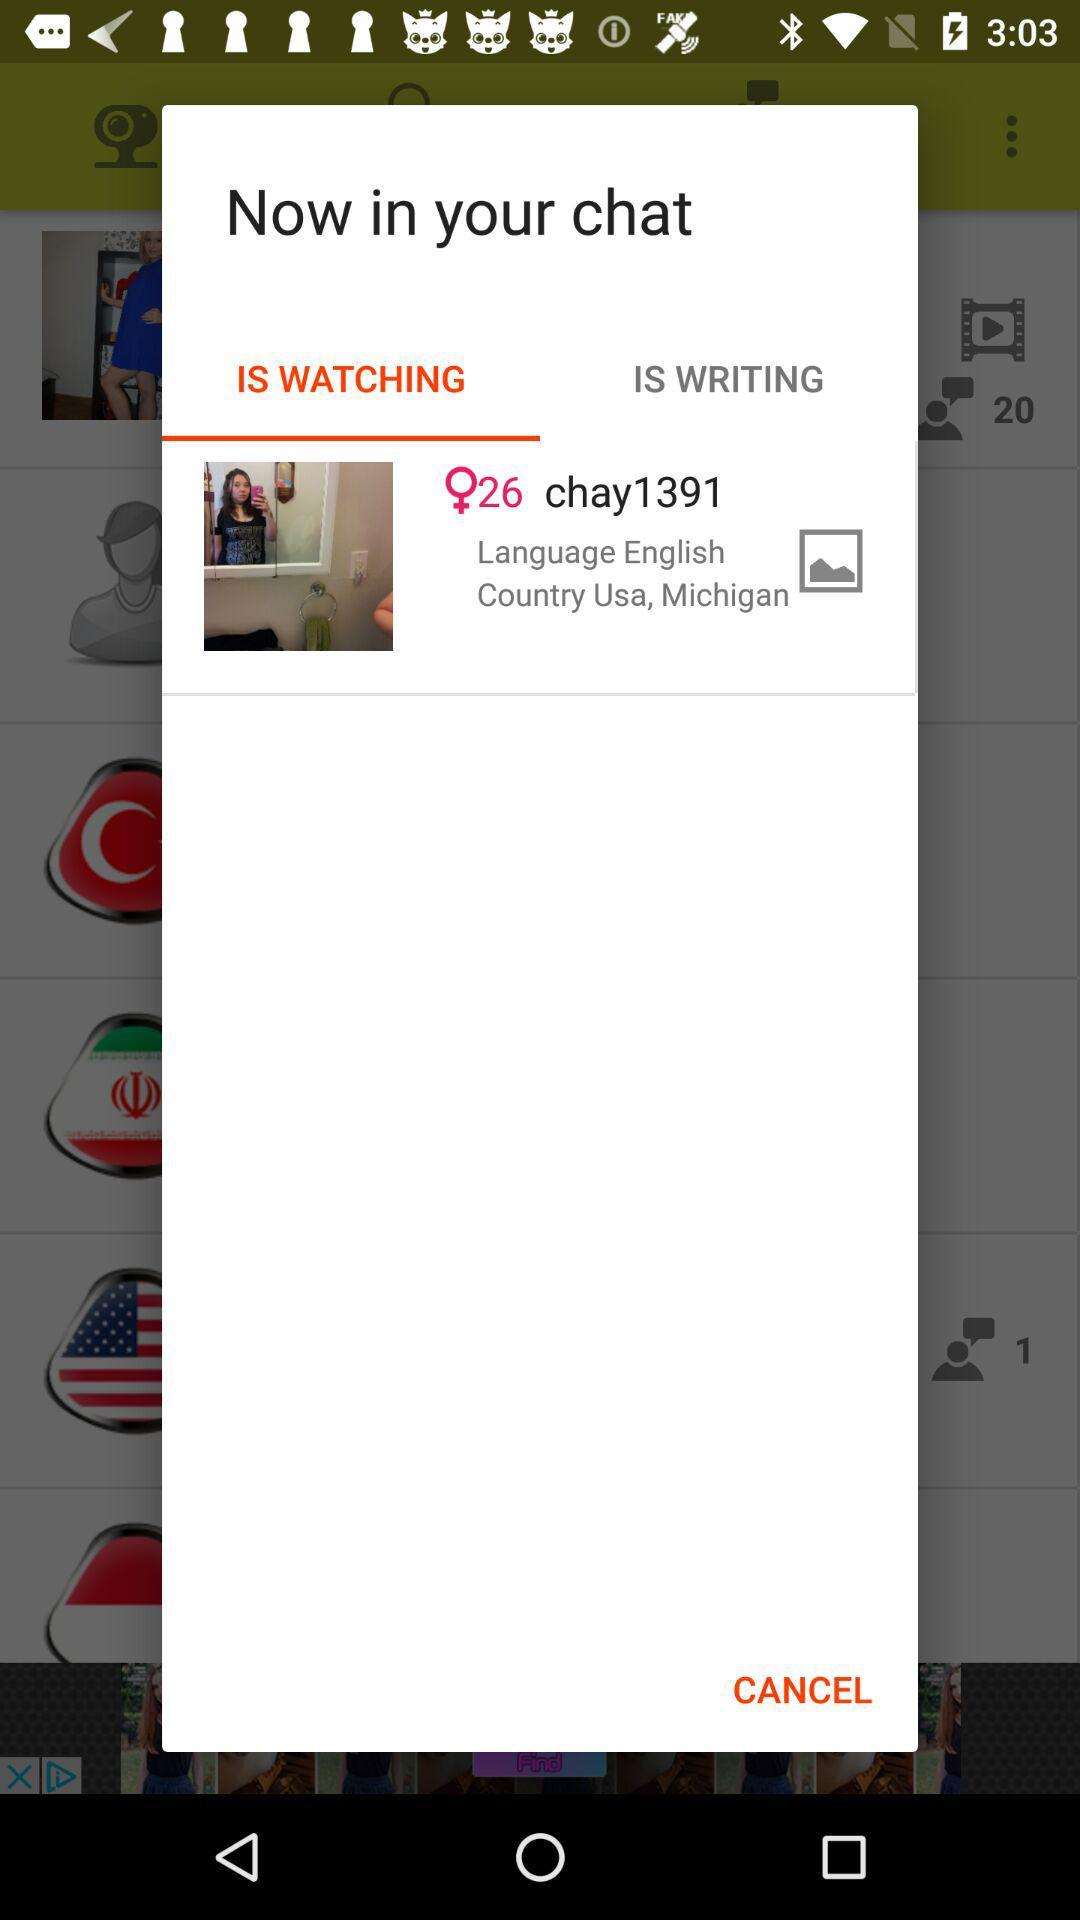What is the user profile name? The user profile name is "chay1391". 